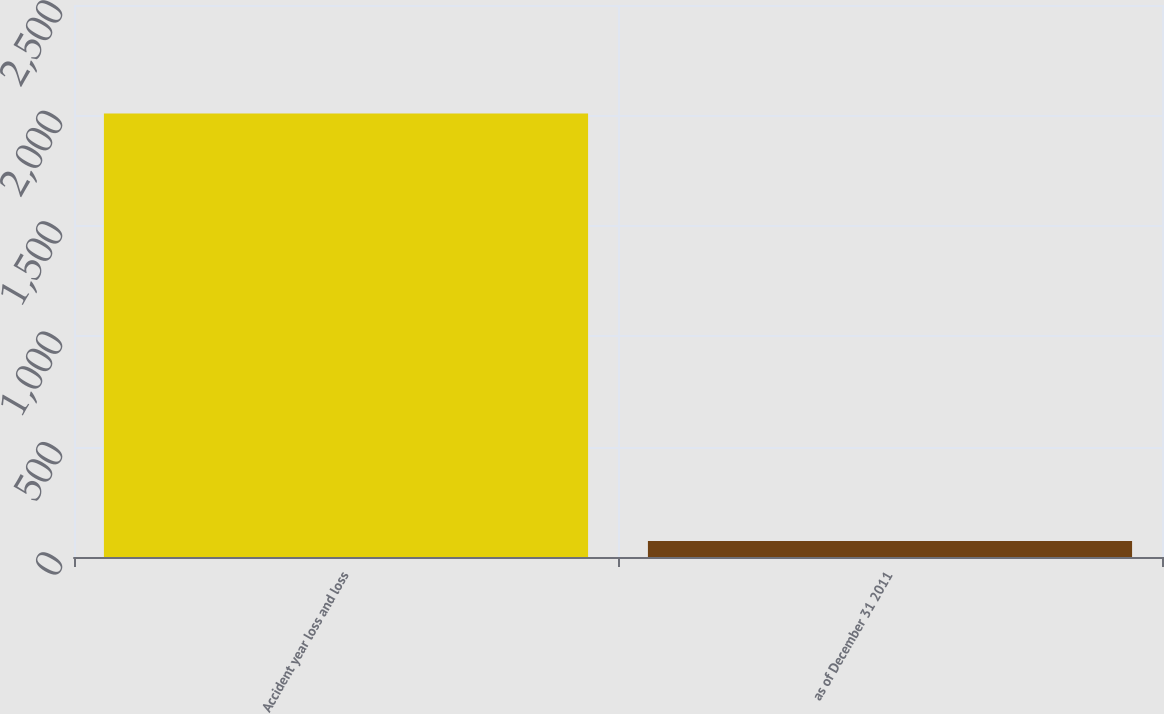<chart> <loc_0><loc_0><loc_500><loc_500><bar_chart><fcel>Accident year loss and loss<fcel>as of December 31 2011<nl><fcel>2009<fcel>71.9<nl></chart> 